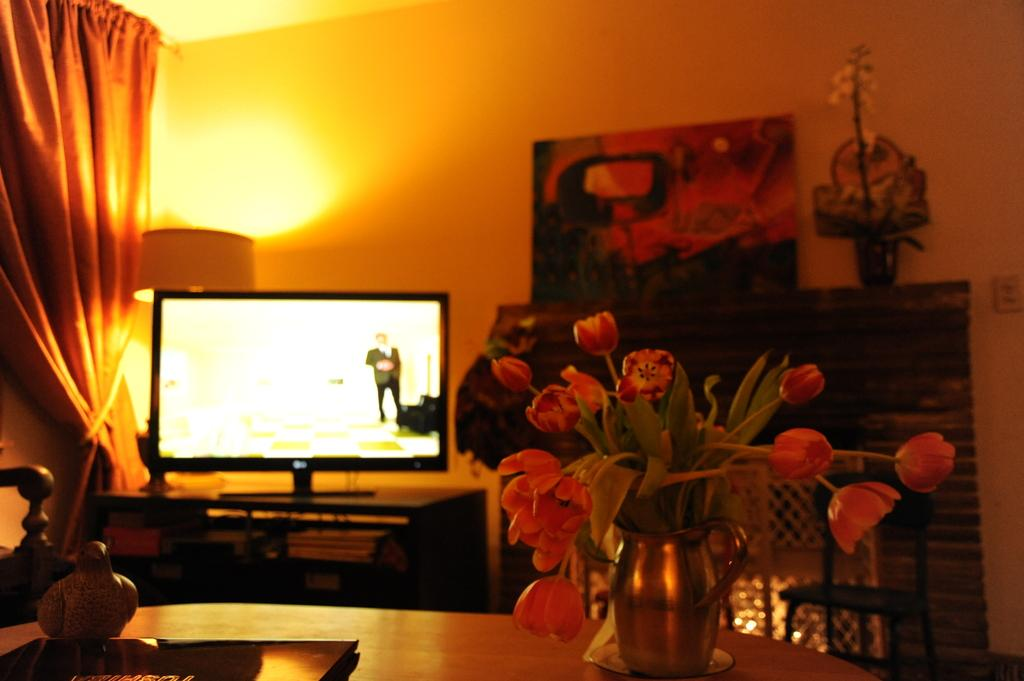What type of structure can be seen in the image? There is a wall in the image. What is hanging on the wall in the image? There is a banner in the image. What type of container for flowers is present in the image? There is a flower flask in the image. What type of window treatment is visible in the image? There is a curtain in the image. What type of display or viewing surface is present in the image? There is a screen in the image. What type of gate is visible in the image? There is no gate present in the image. What type of crib is visible in the image? There is no crib present in the image. 